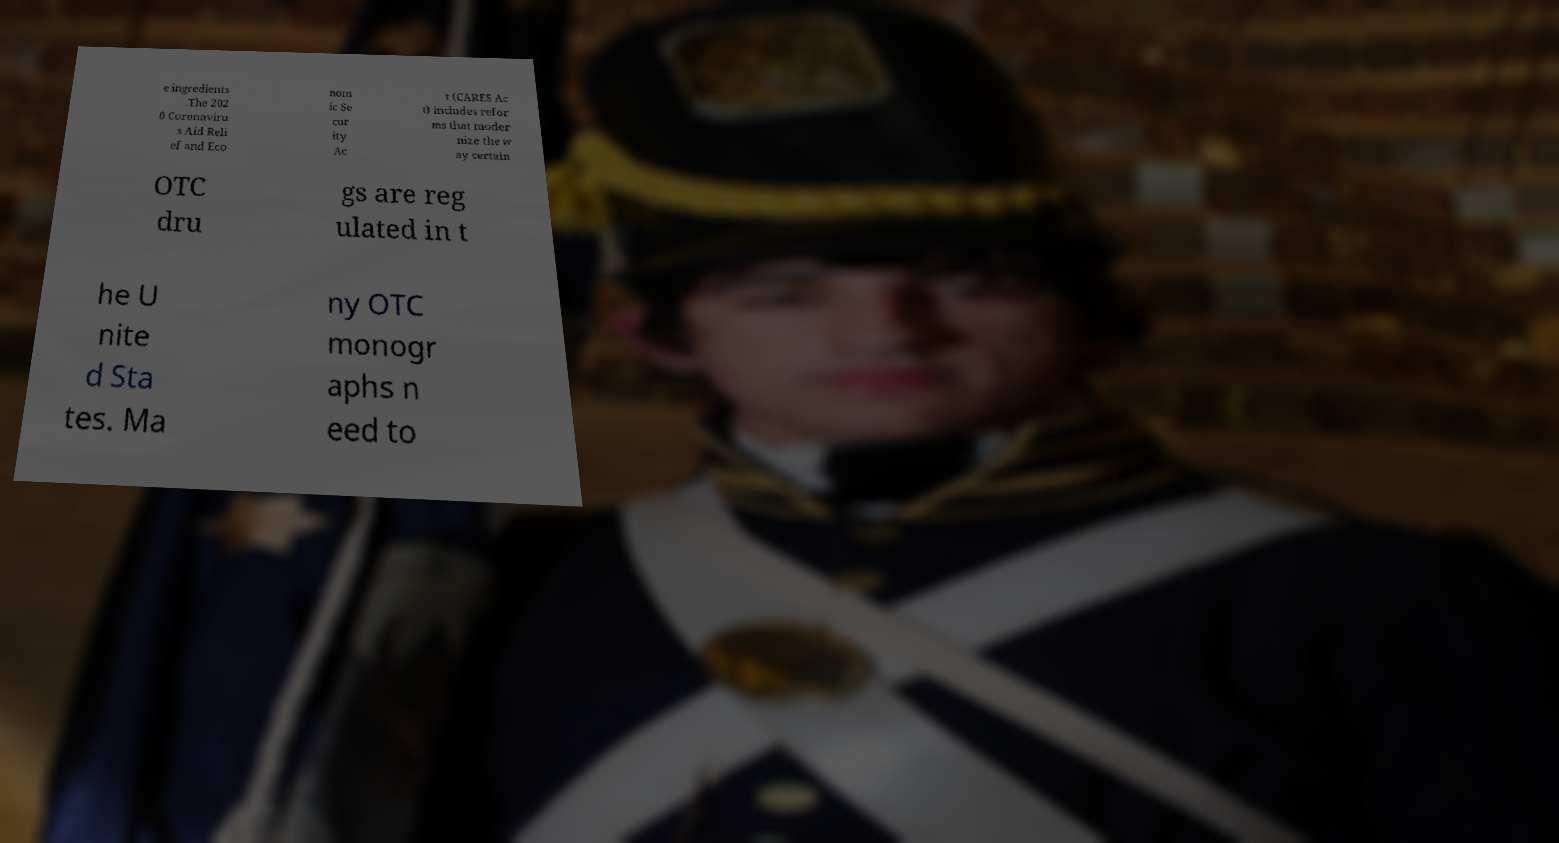There's text embedded in this image that I need extracted. Can you transcribe it verbatim? e ingredients .The 202 0 Coronaviru s Aid Reli ef and Eco nom ic Se cur ity Ac t (CARES Ac t) includes refor ms that moder nize the w ay certain OTC dru gs are reg ulated in t he U nite d Sta tes. Ma ny OTC monogr aphs n eed to 